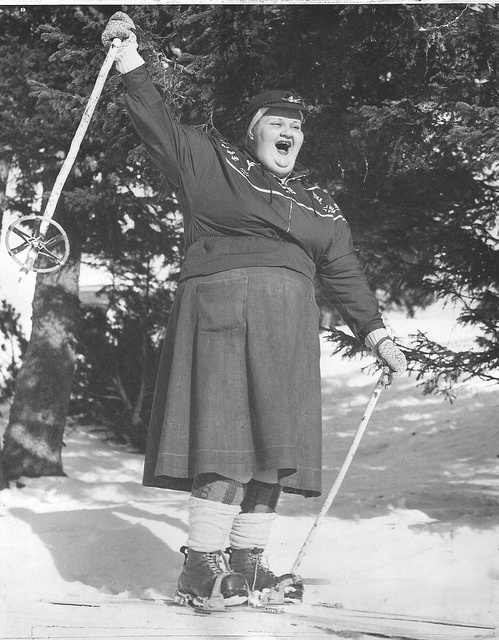Describe the objects in this image and their specific colors. I can see people in white, gray, lightgray, and black tones and skis in lightgray, darkgray, gray, and white tones in this image. 